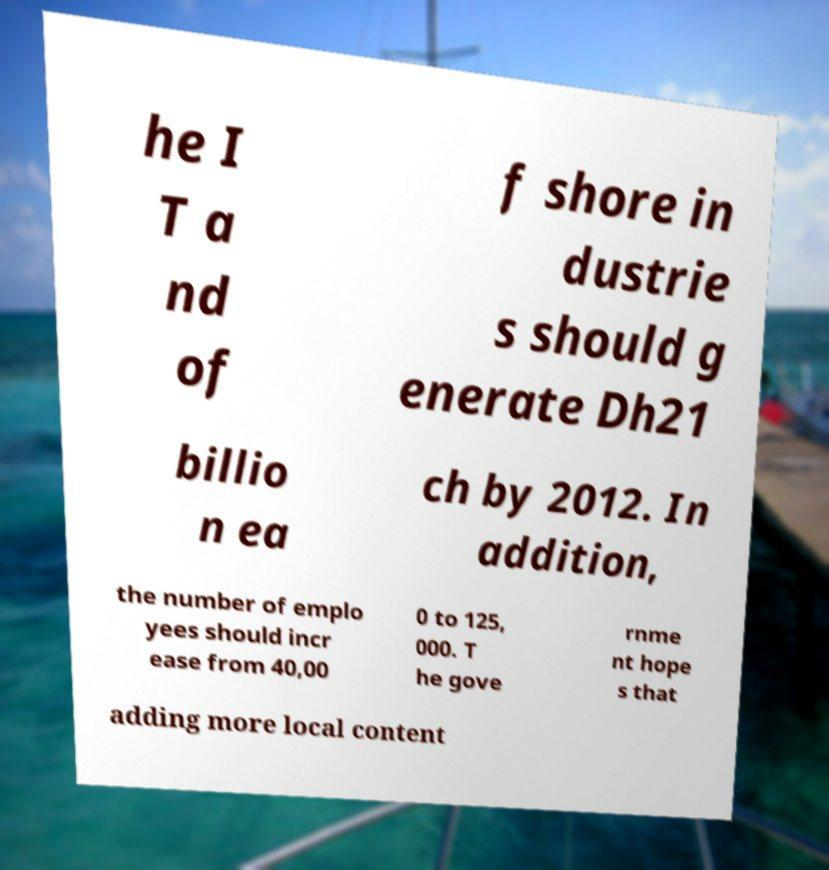Can you accurately transcribe the text from the provided image for me? he I T a nd of f shore in dustrie s should g enerate Dh21 billio n ea ch by 2012. In addition, the number of emplo yees should incr ease from 40,00 0 to 125, 000. T he gove rnme nt hope s that adding more local content 